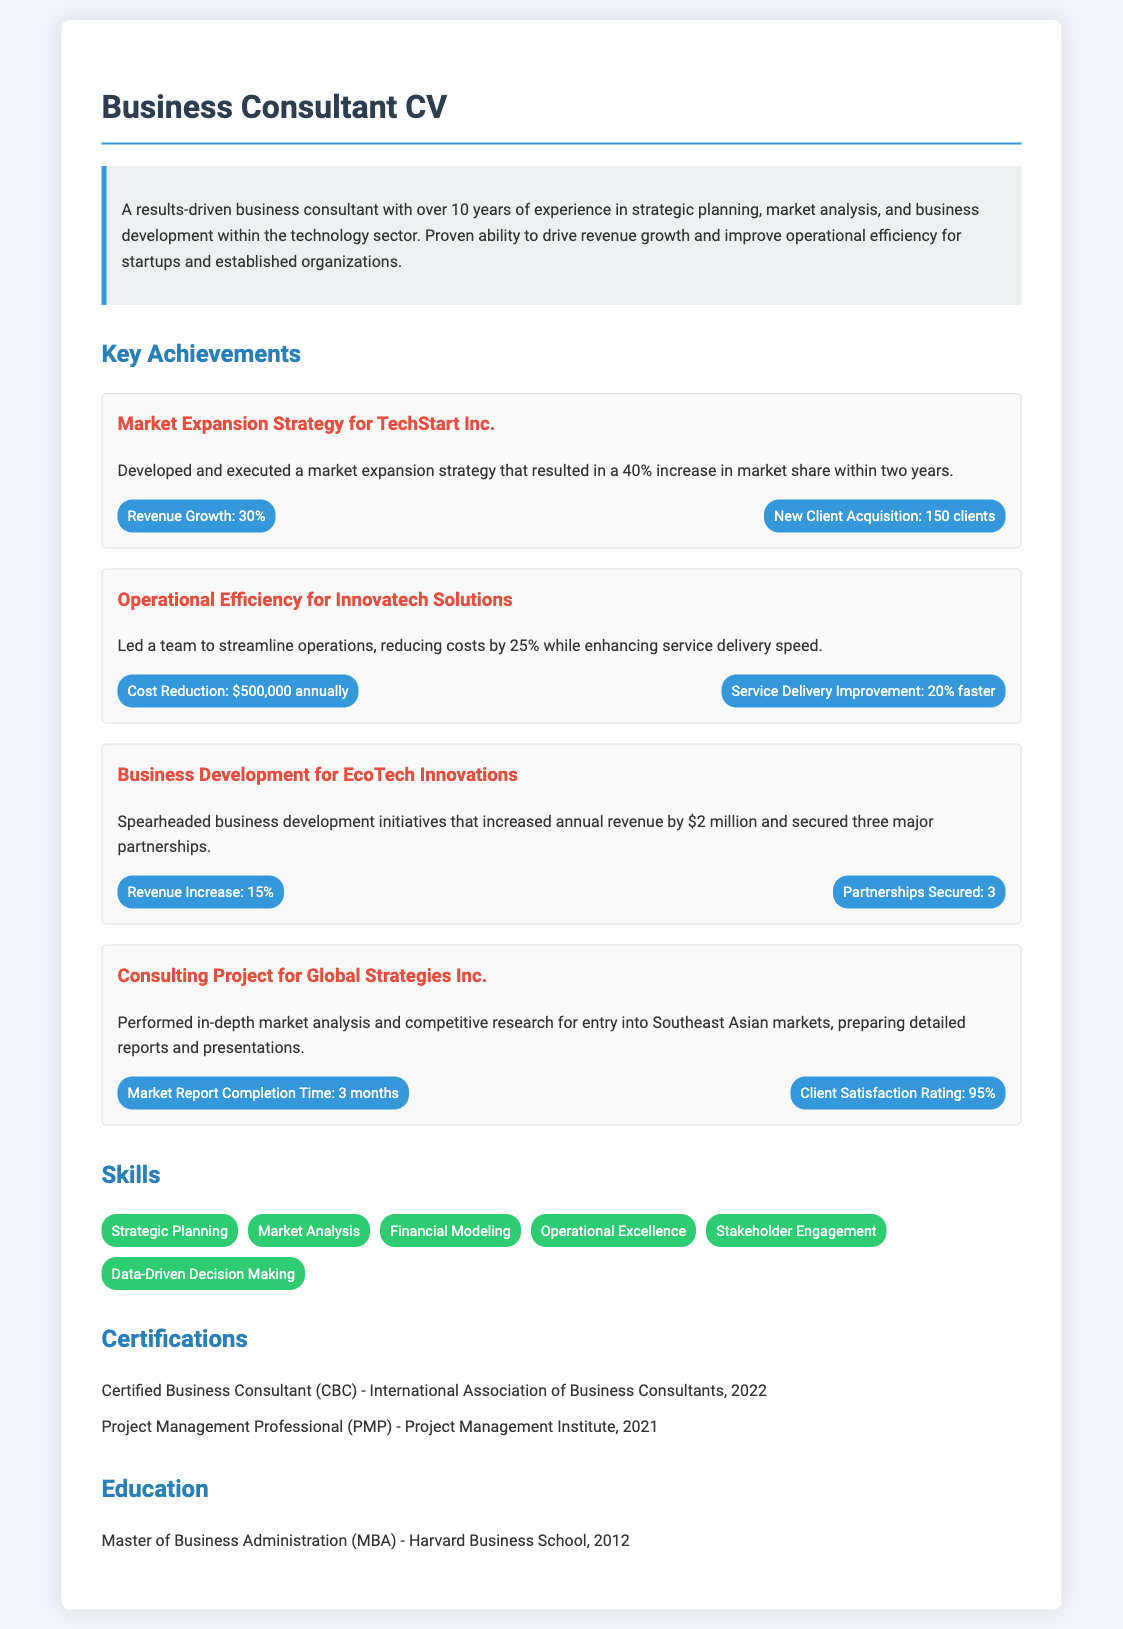What is the total revenue increase for EcoTech Innovations? The total revenue increase is mentioned in the achievement section related to EcoTech Innovations which states an increase of $2 million.
Answer: $2 million How many years of experience does the consultant have? The overview section states that the consultant has over 10 years of experience.
Answer: Over 10 years What is the cost reduction achieved for Innovatech Solutions? The achievement related to Innovatech Solutions specifies that costs were reduced by $500,000 annually.
Answer: $500,000 What was the client satisfaction rating for Global Strategies Inc.? The metrics in the achievement for Global Strategies Inc. notes a client satisfaction rating of 95%.
Answer: 95% How many partnerships were secured by EcoTech Innovations? The achievement for EcoTech Innovations states that three major partnerships were secured.
Answer: 3 By what percentage did market share increase for TechStart Inc.? The market expansion strategy for TechStart Inc. resulted in a 40% increase in market share within two years.
Answer: 40% What skill is related to data-driven decision making? The skills section lists "Data-Driven Decision Making" as one of the key skills of the consultant.
Answer: Data-Driven Decision Making What certification was obtained in 2022? The certifications section mentions that the consultant obtained the Certified Business Consultant (CBC) certification in 2022.
Answer: Certified Business Consultant (CBC) What is the educational qualification of the consultant? The education section states that the consultant has a Master of Business Administration (MBA) from Harvard Business School.
Answer: Master of Business Administration (MBA) 